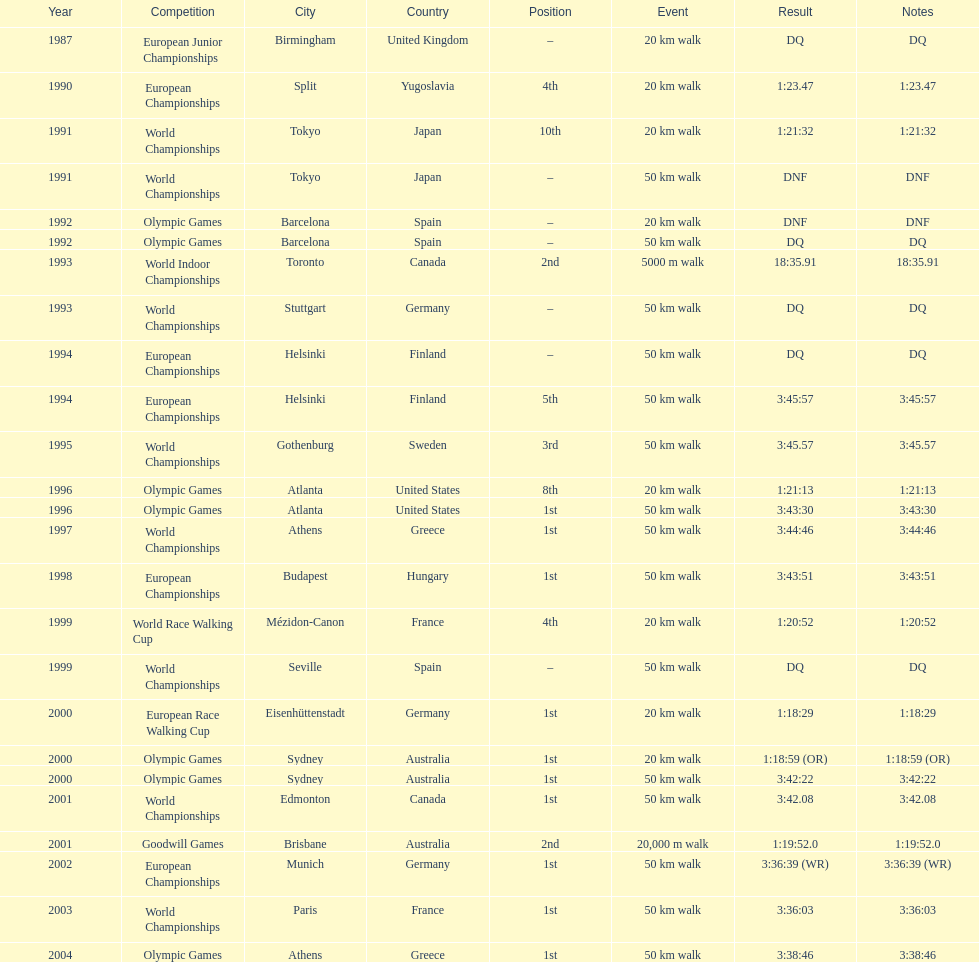How many events were at least 50 km? 17. 